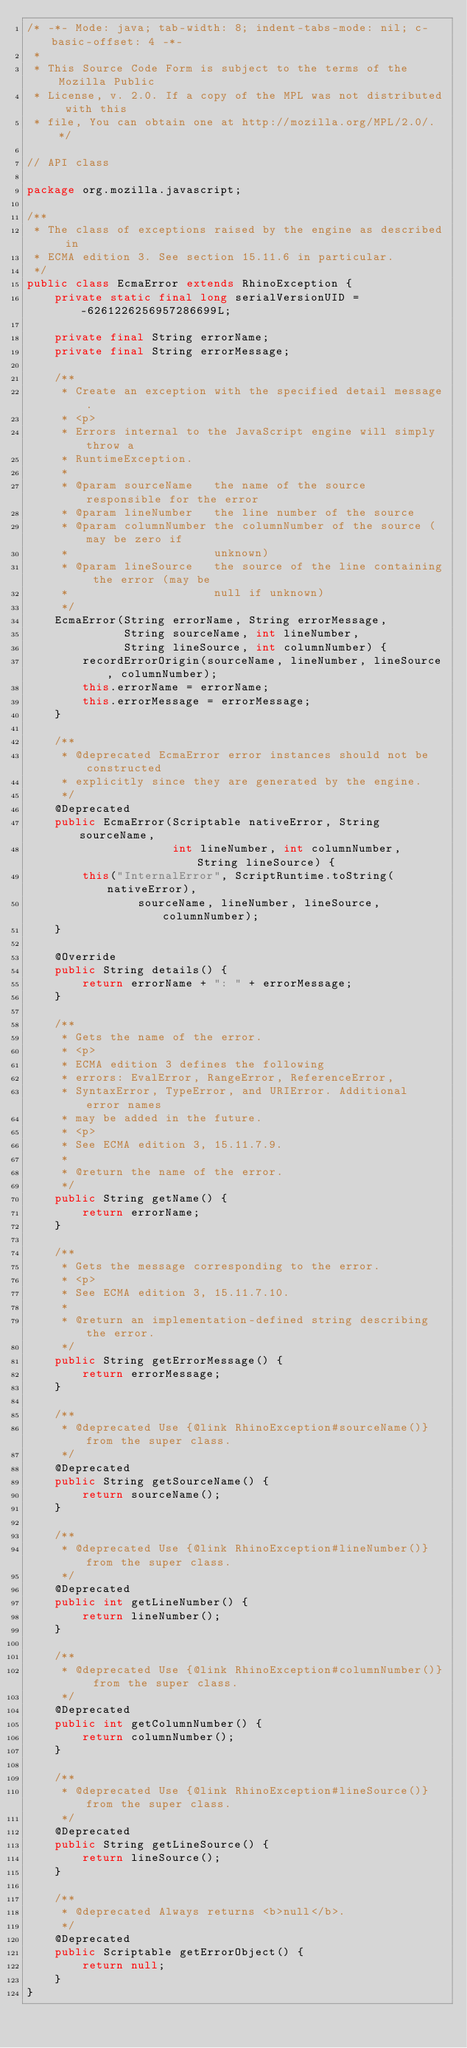Convert code to text. <code><loc_0><loc_0><loc_500><loc_500><_Java_>/* -*- Mode: java; tab-width: 8; indent-tabs-mode: nil; c-basic-offset: 4 -*-
 *
 * This Source Code Form is subject to the terms of the Mozilla Public
 * License, v. 2.0. If a copy of the MPL was not distributed with this
 * file, You can obtain one at http://mozilla.org/MPL/2.0/. */

// API class

package org.mozilla.javascript;

/**
 * The class of exceptions raised by the engine as described in
 * ECMA edition 3. See section 15.11.6 in particular.
 */
public class EcmaError extends RhinoException {
    private static final long serialVersionUID = -6261226256957286699L;

    private final String errorName;
    private final String errorMessage;

    /**
     * Create an exception with the specified detail message.
     * <p>
     * Errors internal to the JavaScript engine will simply throw a
     * RuntimeException.
     *
     * @param sourceName   the name of the source responsible for the error
     * @param lineNumber   the line number of the source
     * @param columnNumber the columnNumber of the source (may be zero if
     *                     unknown)
     * @param lineSource   the source of the line containing the error (may be
     *                     null if unknown)
     */
    EcmaError(String errorName, String errorMessage,
              String sourceName, int lineNumber,
              String lineSource, int columnNumber) {
        recordErrorOrigin(sourceName, lineNumber, lineSource, columnNumber);
        this.errorName = errorName;
        this.errorMessage = errorMessage;
    }

    /**
     * @deprecated EcmaError error instances should not be constructed
     * explicitly since they are generated by the engine.
     */
    @Deprecated
    public EcmaError(Scriptable nativeError, String sourceName,
                     int lineNumber, int columnNumber, String lineSource) {
        this("InternalError", ScriptRuntime.toString(nativeError),
                sourceName, lineNumber, lineSource, columnNumber);
    }

    @Override
    public String details() {
        return errorName + ": " + errorMessage;
    }

    /**
     * Gets the name of the error.
     * <p>
     * ECMA edition 3 defines the following
     * errors: EvalError, RangeError, ReferenceError,
     * SyntaxError, TypeError, and URIError. Additional error names
     * may be added in the future.
     * <p>
     * See ECMA edition 3, 15.11.7.9.
     *
     * @return the name of the error.
     */
    public String getName() {
        return errorName;
    }

    /**
     * Gets the message corresponding to the error.
     * <p>
     * See ECMA edition 3, 15.11.7.10.
     *
     * @return an implementation-defined string describing the error.
     */
    public String getErrorMessage() {
        return errorMessage;
    }

    /**
     * @deprecated Use {@link RhinoException#sourceName()} from the super class.
     */
    @Deprecated
    public String getSourceName() {
        return sourceName();
    }

    /**
     * @deprecated Use {@link RhinoException#lineNumber()} from the super class.
     */
    @Deprecated
    public int getLineNumber() {
        return lineNumber();
    }

    /**
     * @deprecated Use {@link RhinoException#columnNumber()} from the super class.
     */
    @Deprecated
    public int getColumnNumber() {
        return columnNumber();
    }

    /**
     * @deprecated Use {@link RhinoException#lineSource()} from the super class.
     */
    @Deprecated
    public String getLineSource() {
        return lineSource();
    }

    /**
     * @deprecated Always returns <b>null</b>.
     */
    @Deprecated
    public Scriptable getErrorObject() {
        return null;
    }
}
</code> 